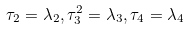<formula> <loc_0><loc_0><loc_500><loc_500>\tau _ { 2 } = \lambda _ { 2 } , \tau _ { 3 } ^ { 2 } = \lambda _ { 3 } , \tau _ { 4 } = \lambda _ { 4 }</formula> 